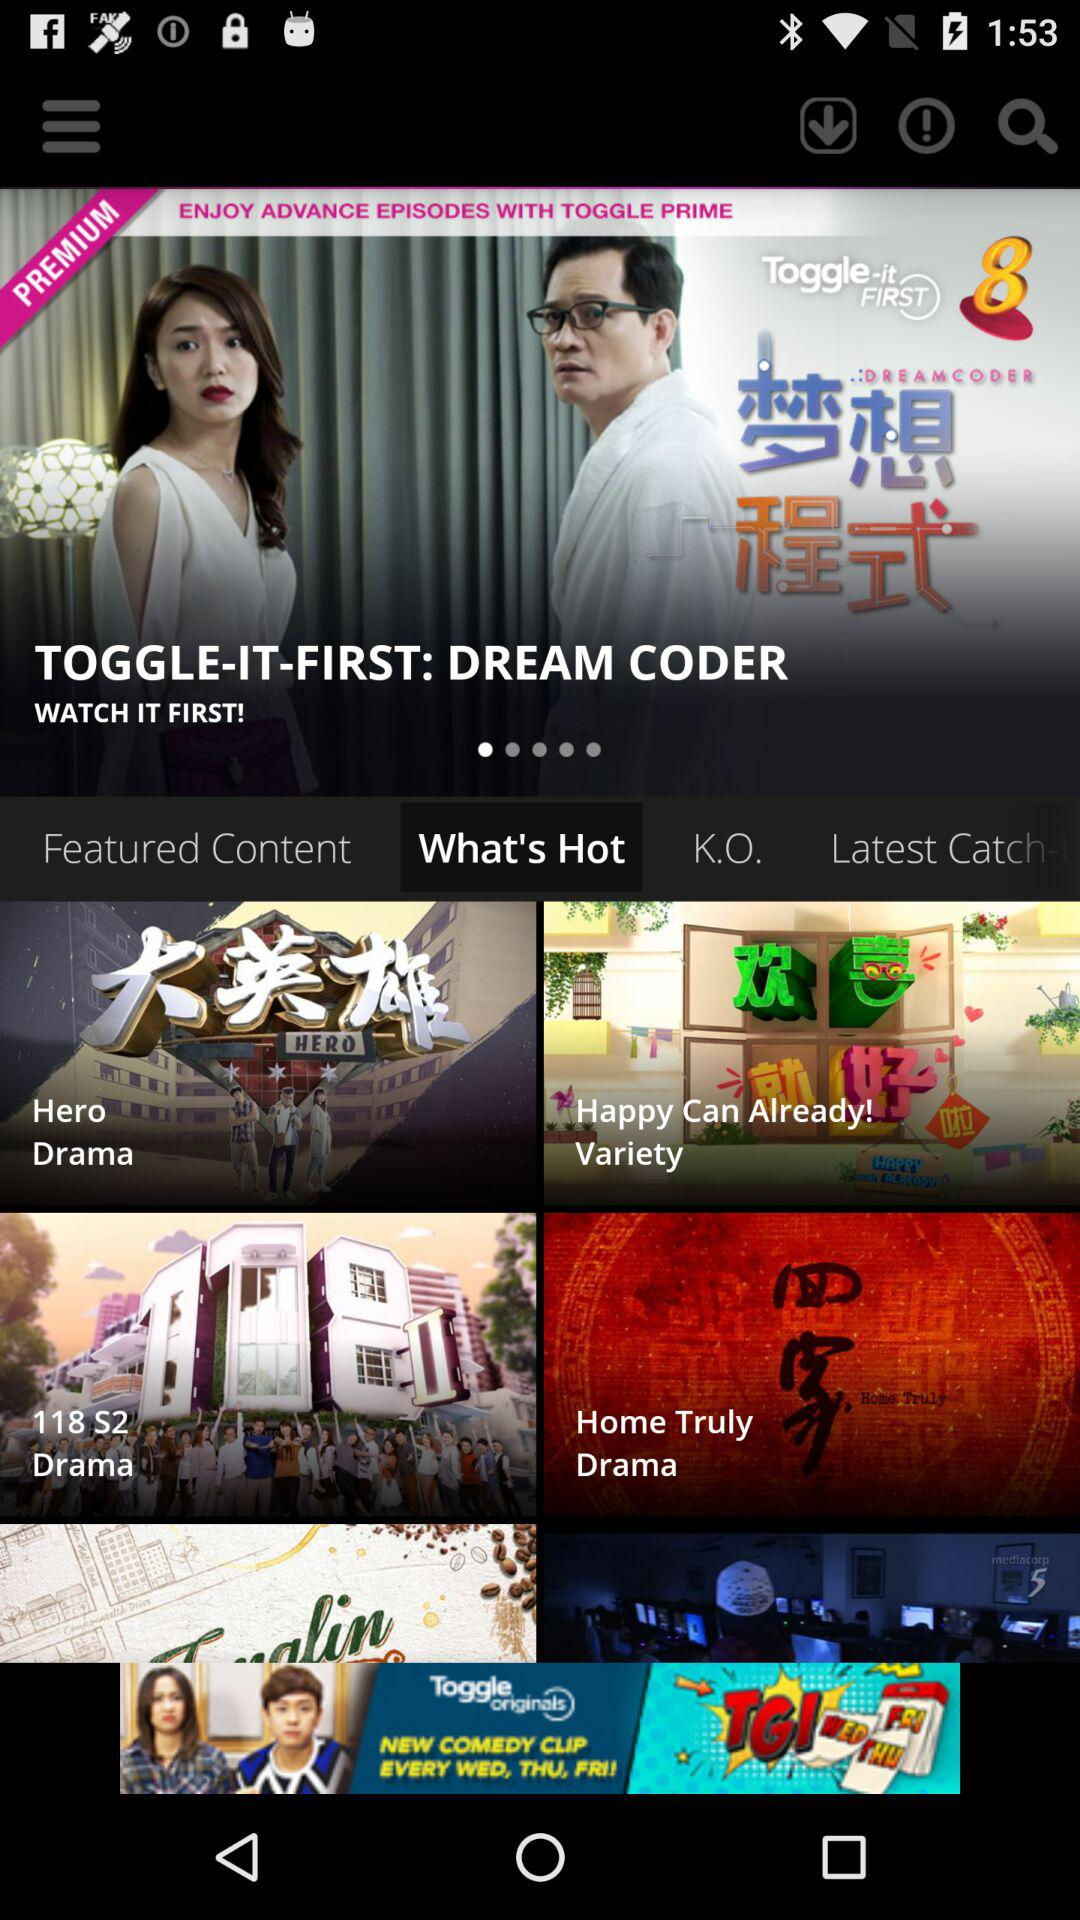What is the selected tab? The selected tab is "What's Hot". 